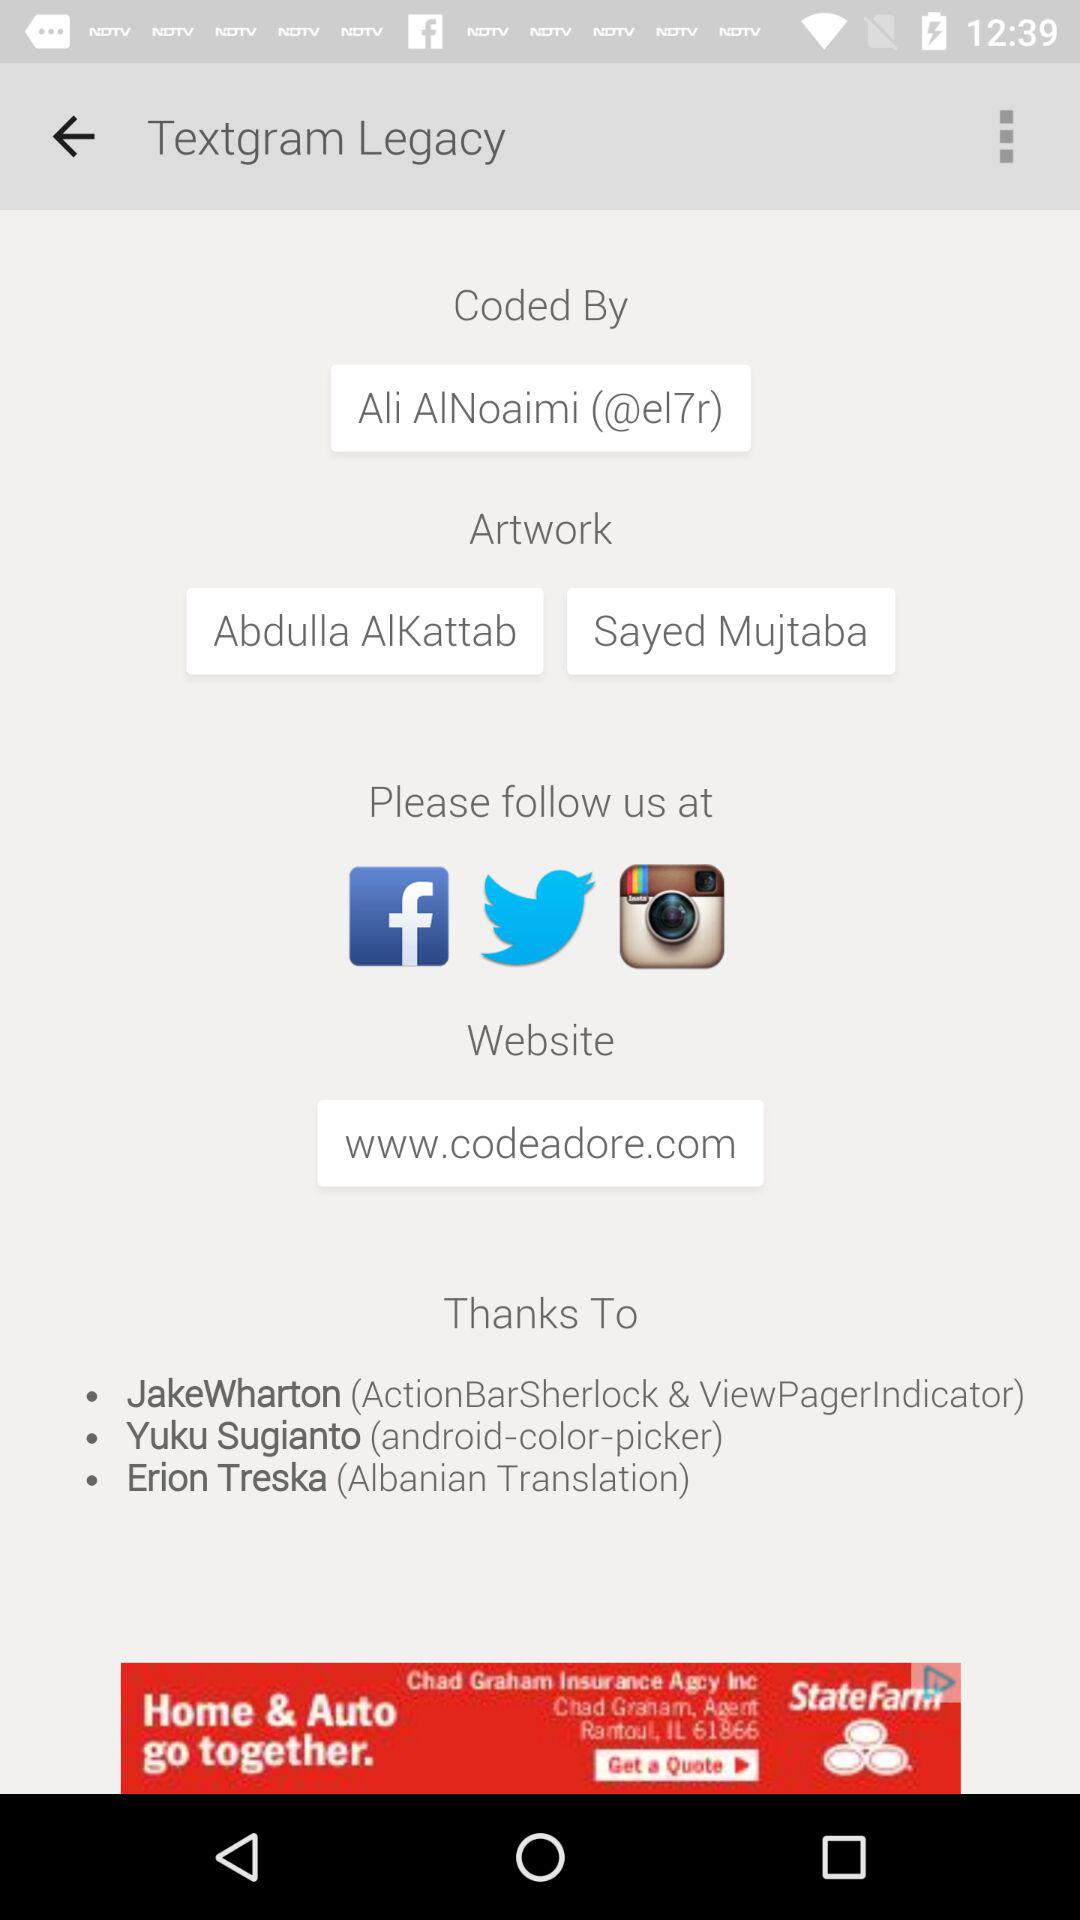Who has done the artwork? The artwork has been done by Abdulla AlKattab and Sayed Mujtaba. 